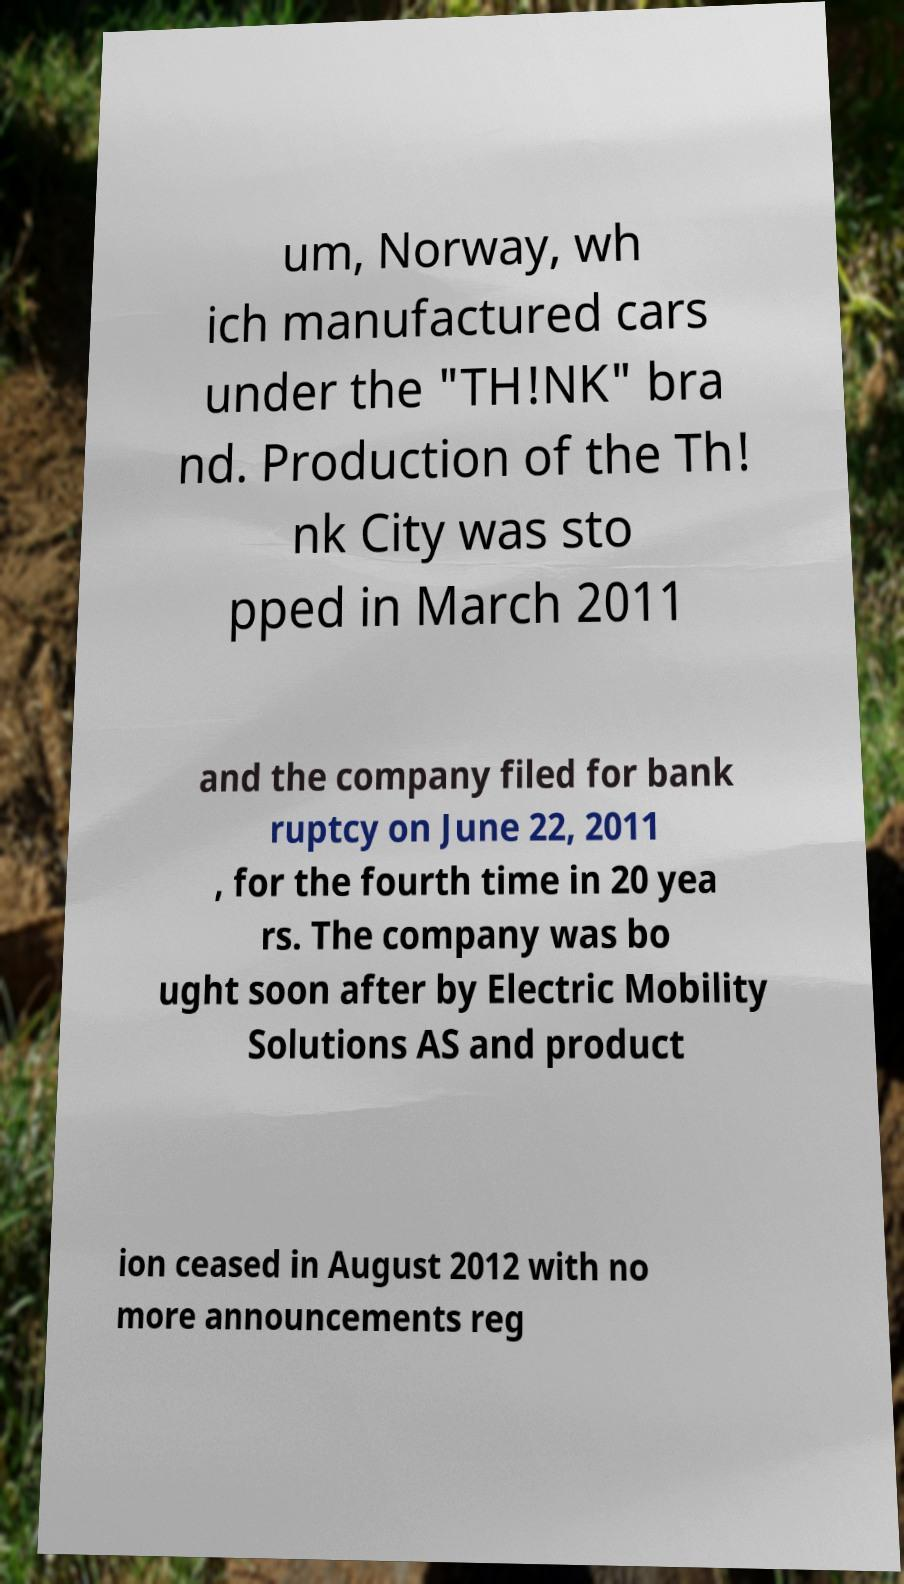Could you extract and type out the text from this image? um, Norway, wh ich manufactured cars under the "TH!NK" bra nd. Production of the Th! nk City was sto pped in March 2011 and the company filed for bank ruptcy on June 22, 2011 , for the fourth time in 20 yea rs. The company was bo ught soon after by Electric Mobility Solutions AS and product ion ceased in August 2012 with no more announcements reg 